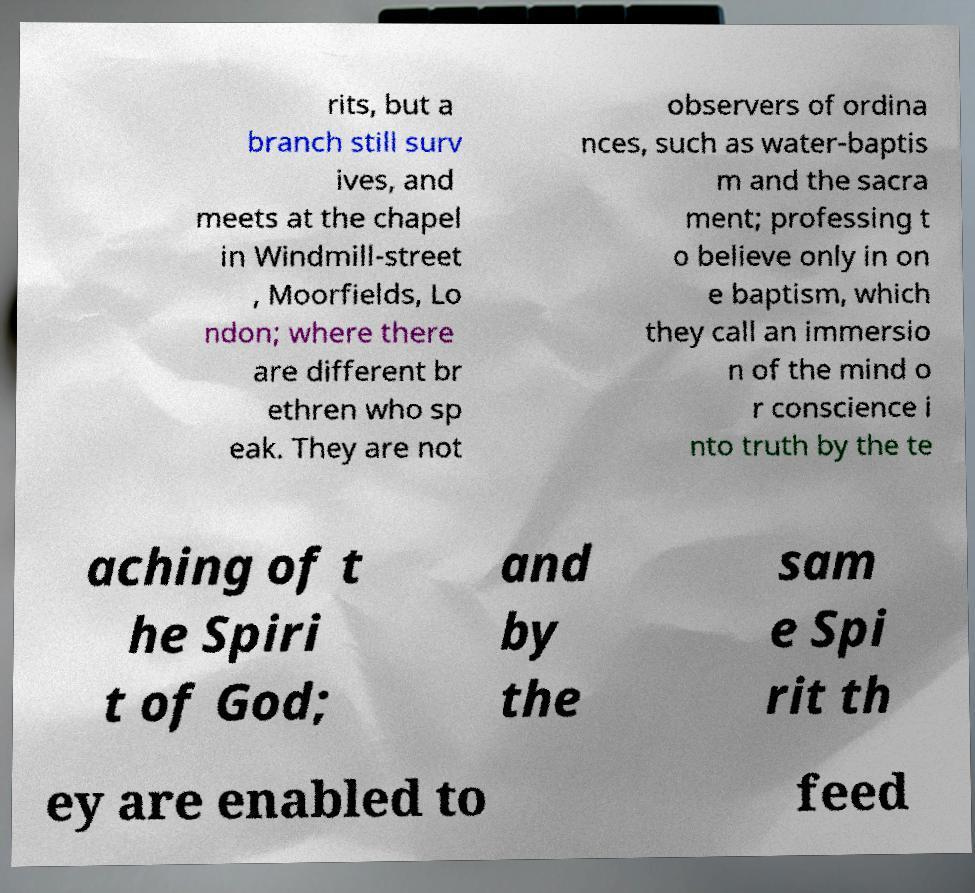There's text embedded in this image that I need extracted. Can you transcribe it verbatim? rits, but a branch still surv ives, and meets at the chapel in Windmill-street , Moorfields, Lo ndon; where there are different br ethren who sp eak. They are not observers of ordina nces, such as water-baptis m and the sacra ment; professing t o believe only in on e baptism, which they call an immersio n of the mind o r conscience i nto truth by the te aching of t he Spiri t of God; and by the sam e Spi rit th ey are enabled to feed 